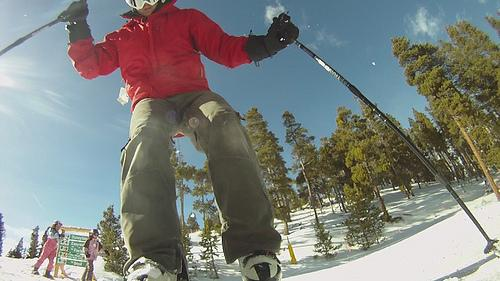Why does the person have poles?

Choices:
A) balance
B) visibility
C) fashion
D) protection balance 